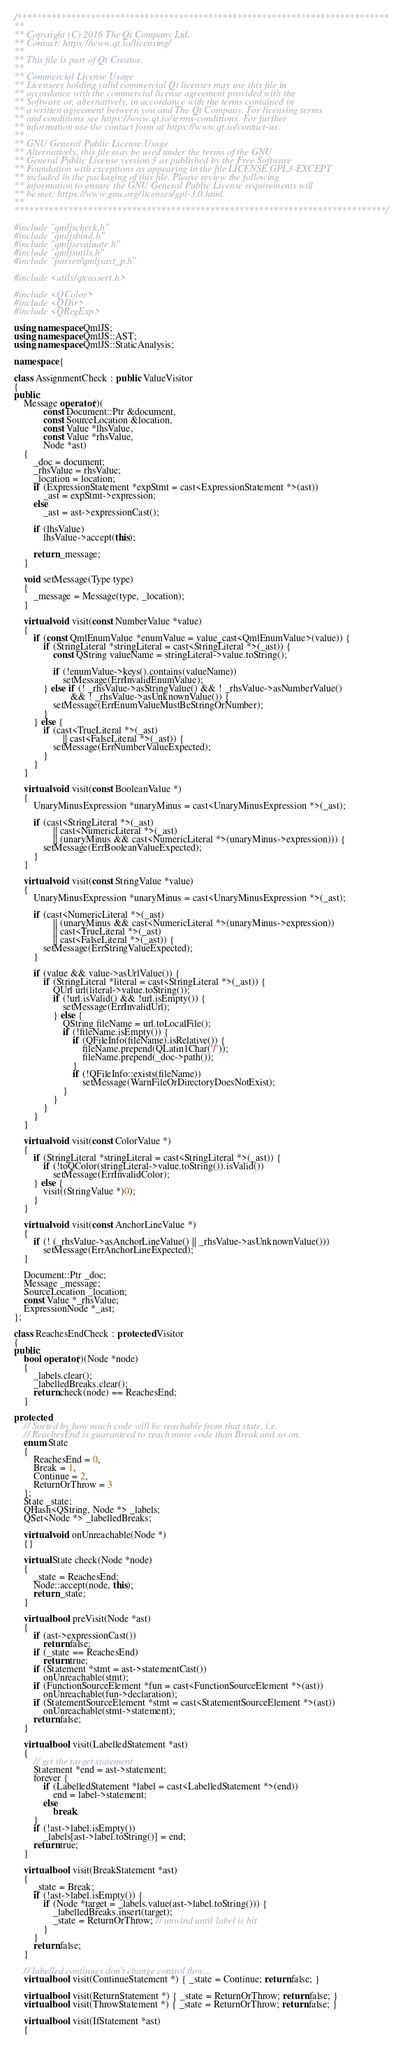Convert code to text. <code><loc_0><loc_0><loc_500><loc_500><_C++_>/****************************************************************************
**
** Copyright (C) 2016 The Qt Company Ltd.
** Contact: https://www.qt.io/licensing/
**
** This file is part of Qt Creator.
**
** Commercial License Usage
** Licensees holding valid commercial Qt licenses may use this file in
** accordance with the commercial license agreement provided with the
** Software or, alternatively, in accordance with the terms contained in
** a written agreement between you and The Qt Company. For licensing terms
** and conditions see https://www.qt.io/terms-conditions. For further
** information use the contact form at https://www.qt.io/contact-us.
**
** GNU General Public License Usage
** Alternatively, this file may be used under the terms of the GNU
** General Public License version 3 as published by the Free Software
** Foundation with exceptions as appearing in the file LICENSE.GPL3-EXCEPT
** included in the packaging of this file. Please review the following
** information to ensure the GNU General Public License requirements will
** be met: https://www.gnu.org/licenses/gpl-3.0.html.
**
****************************************************************************/

#include "qmljscheck.h"
#include "qmljsbind.h"
#include "qmljsevaluate.h"
#include "qmljsutils.h"
#include "parser/qmljsast_p.h"

#include <utils/qtcassert.h>

#include <QColor>
#include <QDir>
#include <QRegExp>

using namespace QmlJS;
using namespace QmlJS::AST;
using namespace QmlJS::StaticAnalysis;

namespace {

class AssignmentCheck : public ValueVisitor
{
public:
    Message operator()(
            const Document::Ptr &document,
            const SourceLocation &location,
            const Value *lhsValue,
            const Value *rhsValue,
            Node *ast)
    {
        _doc = document;
        _rhsValue = rhsValue;
        _location = location;
        if (ExpressionStatement *expStmt = cast<ExpressionStatement *>(ast))
            _ast = expStmt->expression;
        else
            _ast = ast->expressionCast();

        if (lhsValue)
            lhsValue->accept(this);

        return _message;
    }

    void setMessage(Type type)
    {
        _message = Message(type, _location);
    }

    virtual void visit(const NumberValue *value)
    {
        if (const QmlEnumValue *enumValue = value_cast<QmlEnumValue>(value)) {
            if (StringLiteral *stringLiteral = cast<StringLiteral *>(_ast)) {
                const QString valueName = stringLiteral->value.toString();

                if (!enumValue->keys().contains(valueName))
                    setMessage(ErrInvalidEnumValue);
            } else if (! _rhsValue->asStringValue() && ! _rhsValue->asNumberValue()
                       && ! _rhsValue->asUnknownValue()) {
                setMessage(ErrEnumValueMustBeStringOrNumber);
            }
        } else {
            if (cast<TrueLiteral *>(_ast)
                    || cast<FalseLiteral *>(_ast)) {
                setMessage(ErrNumberValueExpected);
            }
        }
    }

    virtual void visit(const BooleanValue *)
    {
        UnaryMinusExpression *unaryMinus = cast<UnaryMinusExpression *>(_ast);

        if (cast<StringLiteral *>(_ast)
                || cast<NumericLiteral *>(_ast)
                || (unaryMinus && cast<NumericLiteral *>(unaryMinus->expression))) {
            setMessage(ErrBooleanValueExpected);
        }
    }

    virtual void visit(const StringValue *value)
    {
        UnaryMinusExpression *unaryMinus = cast<UnaryMinusExpression *>(_ast);

        if (cast<NumericLiteral *>(_ast)
                || (unaryMinus && cast<NumericLiteral *>(unaryMinus->expression))
                || cast<TrueLiteral *>(_ast)
                || cast<FalseLiteral *>(_ast)) {
            setMessage(ErrStringValueExpected);
        }

        if (value && value->asUrlValue()) {
            if (StringLiteral *literal = cast<StringLiteral *>(_ast)) {
                QUrl url(literal->value.toString());
                if (!url.isValid() && !url.isEmpty()) {
                    setMessage(ErrInvalidUrl);
                } else {
                    QString fileName = url.toLocalFile();
                    if (!fileName.isEmpty()) {
                        if (QFileInfo(fileName).isRelative()) {
                            fileName.prepend(QLatin1Char('/'));
                            fileName.prepend(_doc->path());
                        }
                        if (!QFileInfo::exists(fileName))
                            setMessage(WarnFileOrDirectoryDoesNotExist);
                    }
                }
            }
        }
    }

    virtual void visit(const ColorValue *)
    {
        if (StringLiteral *stringLiteral = cast<StringLiteral *>(_ast)) {
            if (!toQColor(stringLiteral->value.toString()).isValid())
                setMessage(ErrInvalidColor);
        } else {
            visit((StringValue *)0);
        }
    }

    virtual void visit(const AnchorLineValue *)
    {
        if (! (_rhsValue->asAnchorLineValue() || _rhsValue->asUnknownValue()))
            setMessage(ErrAnchorLineExpected);
    }

    Document::Ptr _doc;
    Message _message;
    SourceLocation _location;
    const Value *_rhsValue;
    ExpressionNode *_ast;
};

class ReachesEndCheck : protected Visitor
{
public:
    bool operator()(Node *node)
    {
        _labels.clear();
        _labelledBreaks.clear();
        return check(node) == ReachesEnd;
    }

protected:
    // Sorted by how much code will be reachable from that state, i.e.
    // ReachesEnd is guaranteed to reach more code than Break and so on.
    enum State
    {
        ReachesEnd = 0,
        Break = 1,
        Continue = 2,
        ReturnOrThrow = 3
    };
    State _state;
    QHash<QString, Node *> _labels;
    QSet<Node *> _labelledBreaks;

    virtual void onUnreachable(Node *)
    {}

    virtual State check(Node *node)
    {
        _state = ReachesEnd;
        Node::accept(node, this);
        return _state;
    }

    virtual bool preVisit(Node *ast)
    {
        if (ast->expressionCast())
            return false;
        if (_state == ReachesEnd)
            return true;
        if (Statement *stmt = ast->statementCast())
            onUnreachable(stmt);
        if (FunctionSourceElement *fun = cast<FunctionSourceElement *>(ast))
            onUnreachable(fun->declaration);
        if (StatementSourceElement *stmt = cast<StatementSourceElement *>(ast))
            onUnreachable(stmt->statement);
        return false;
    }

    virtual bool visit(LabelledStatement *ast)
    {
        // get the target statement
        Statement *end = ast->statement;
        forever {
            if (LabelledStatement *label = cast<LabelledStatement *>(end))
                end = label->statement;
            else
                break;
        }
        if (!ast->label.isEmpty())
            _labels[ast->label.toString()] = end;
        return true;
    }

    virtual bool visit(BreakStatement *ast)
    {
        _state = Break;
        if (!ast->label.isEmpty()) {
            if (Node *target = _labels.value(ast->label.toString())) {
                _labelledBreaks.insert(target);
                _state = ReturnOrThrow; // unwind until label is hit
            }
        }
        return false;
    }

    // labelled continues don't change control flow...
    virtual bool visit(ContinueStatement *) { _state = Continue; return false; }

    virtual bool visit(ReturnStatement *) { _state = ReturnOrThrow; return false; }
    virtual bool visit(ThrowStatement *) { _state = ReturnOrThrow; return false; }

    virtual bool visit(IfStatement *ast)
    {</code> 